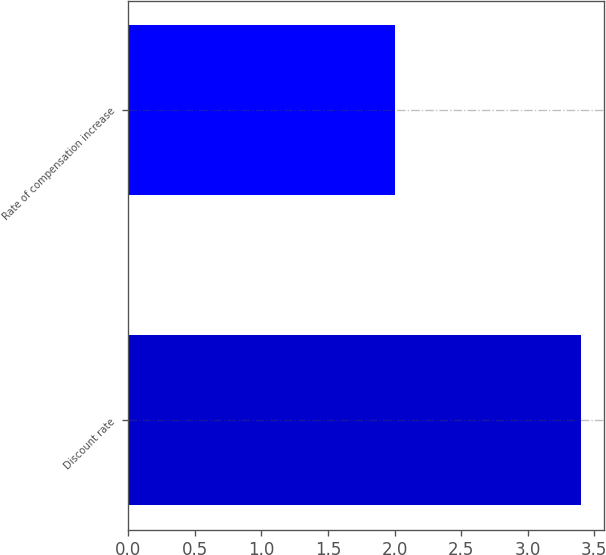Convert chart to OTSL. <chart><loc_0><loc_0><loc_500><loc_500><bar_chart><fcel>Discount rate<fcel>Rate of compensation increase<nl><fcel>3.4<fcel>2<nl></chart> 